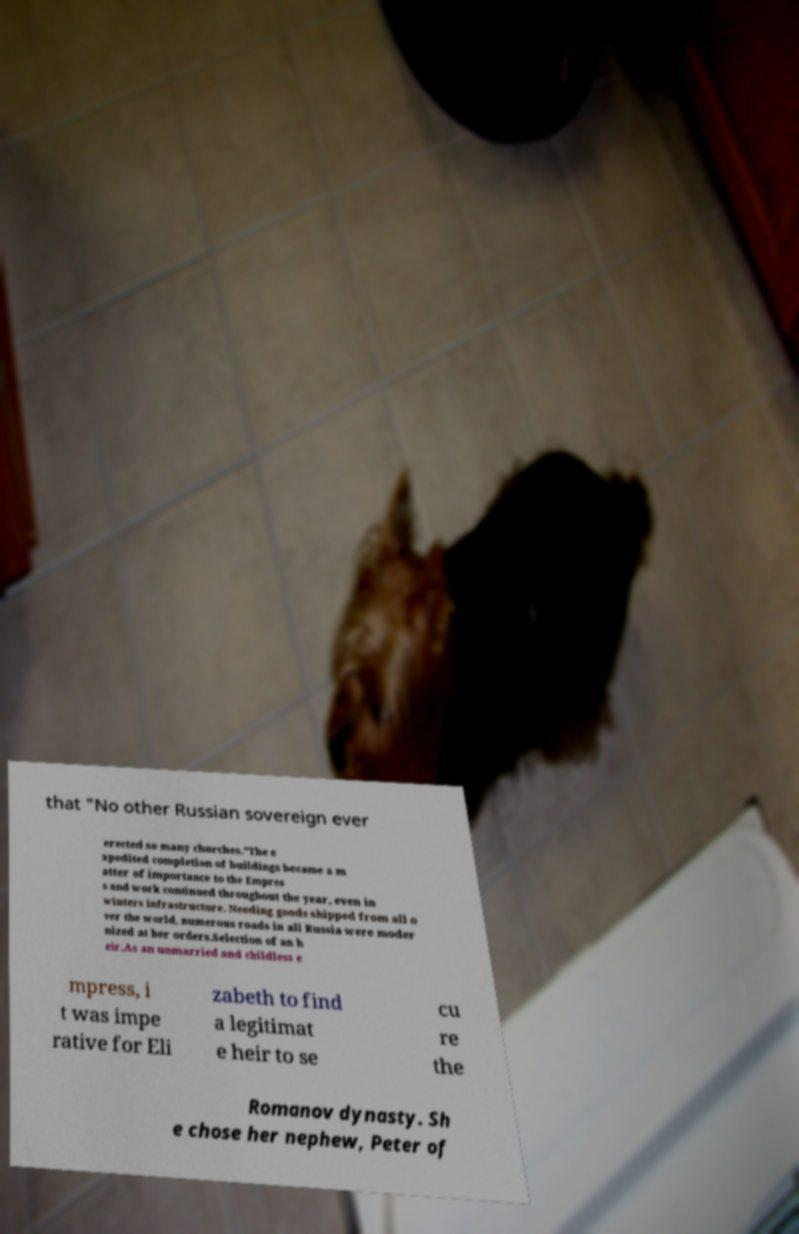I need the written content from this picture converted into text. Can you do that? that "No other Russian sovereign ever erected so many churches."The e xpedited completion of buildings became a m atter of importance to the Empres s and work continued throughout the year, even in winters infrastructure. Needing goods shipped from all o ver the world, numerous roads in all Russia were moder nized at her orders.Selection of an h eir.As an unmarried and childless e mpress, i t was impe rative for Eli zabeth to find a legitimat e heir to se cu re the Romanov dynasty. Sh e chose her nephew, Peter of 